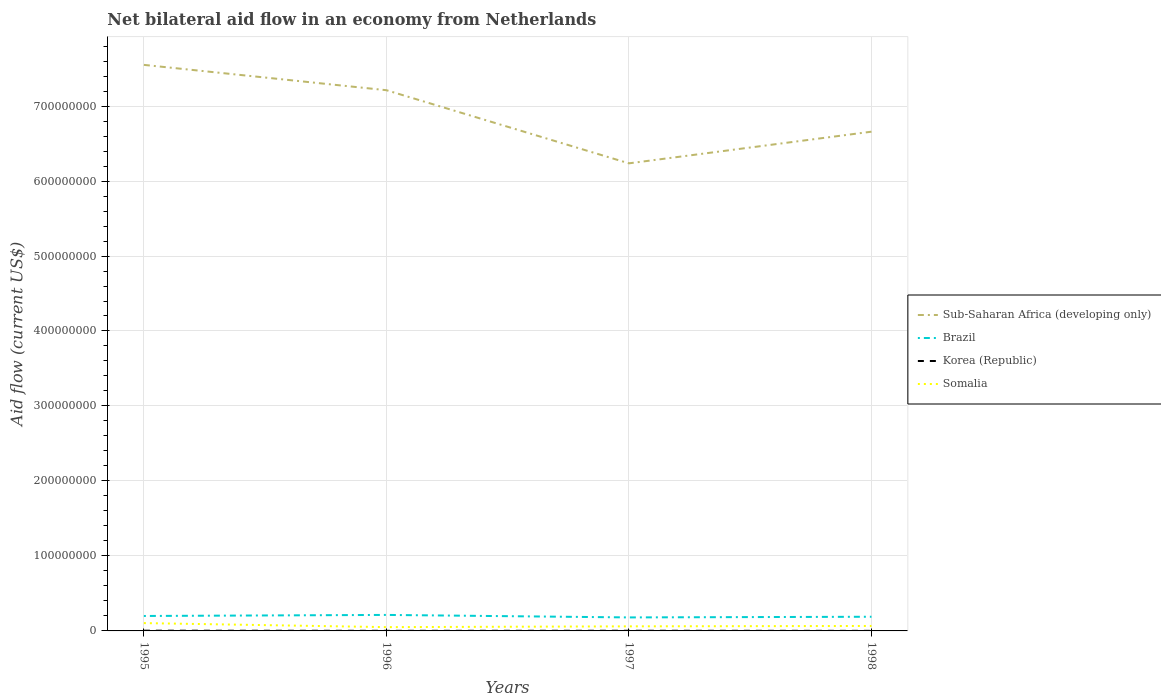Across all years, what is the maximum net bilateral aid flow in Sub-Saharan Africa (developing only)?
Make the answer very short. 6.24e+08. In which year was the net bilateral aid flow in Korea (Republic) maximum?
Offer a terse response. 1998. What is the total net bilateral aid flow in Brazil in the graph?
Keep it short and to the point. 2.44e+06. What is the difference between the highest and the second highest net bilateral aid flow in Brazil?
Ensure brevity in your answer.  3.34e+06. What is the difference between the highest and the lowest net bilateral aid flow in Brazil?
Make the answer very short. 2. How many years are there in the graph?
Keep it short and to the point. 4. What is the difference between two consecutive major ticks on the Y-axis?
Ensure brevity in your answer.  1.00e+08. Are the values on the major ticks of Y-axis written in scientific E-notation?
Keep it short and to the point. No. Does the graph contain any zero values?
Your answer should be compact. No. How many legend labels are there?
Make the answer very short. 4. How are the legend labels stacked?
Your answer should be very brief. Vertical. What is the title of the graph?
Your answer should be very brief. Net bilateral aid flow in an economy from Netherlands. Does "Malta" appear as one of the legend labels in the graph?
Provide a succinct answer. No. What is the label or title of the X-axis?
Offer a terse response. Years. What is the Aid flow (current US$) of Sub-Saharan Africa (developing only) in 1995?
Offer a very short reply. 7.55e+08. What is the Aid flow (current US$) in Brazil in 1995?
Offer a terse response. 1.99e+07. What is the Aid flow (current US$) in Korea (Republic) in 1995?
Provide a short and direct response. 3.20e+05. What is the Aid flow (current US$) of Somalia in 1995?
Give a very brief answer. 1.04e+07. What is the Aid flow (current US$) in Sub-Saharan Africa (developing only) in 1996?
Make the answer very short. 7.21e+08. What is the Aid flow (current US$) of Brazil in 1996?
Make the answer very short. 2.13e+07. What is the Aid flow (current US$) in Somalia in 1996?
Ensure brevity in your answer.  5.05e+06. What is the Aid flow (current US$) in Sub-Saharan Africa (developing only) in 1997?
Provide a short and direct response. 6.24e+08. What is the Aid flow (current US$) of Brazil in 1997?
Make the answer very short. 1.80e+07. What is the Aid flow (current US$) of Somalia in 1997?
Your answer should be very brief. 6.10e+06. What is the Aid flow (current US$) in Sub-Saharan Africa (developing only) in 1998?
Ensure brevity in your answer.  6.66e+08. What is the Aid flow (current US$) in Brazil in 1998?
Your answer should be compact. 1.89e+07. What is the Aid flow (current US$) in Somalia in 1998?
Your answer should be very brief. 6.62e+06. Across all years, what is the maximum Aid flow (current US$) of Sub-Saharan Africa (developing only)?
Provide a succinct answer. 7.55e+08. Across all years, what is the maximum Aid flow (current US$) in Brazil?
Offer a very short reply. 2.13e+07. Across all years, what is the maximum Aid flow (current US$) in Korea (Republic)?
Your response must be concise. 3.20e+05. Across all years, what is the maximum Aid flow (current US$) in Somalia?
Offer a very short reply. 1.04e+07. Across all years, what is the minimum Aid flow (current US$) in Sub-Saharan Africa (developing only)?
Ensure brevity in your answer.  6.24e+08. Across all years, what is the minimum Aid flow (current US$) of Brazil?
Provide a short and direct response. 1.80e+07. Across all years, what is the minimum Aid flow (current US$) of Somalia?
Keep it short and to the point. 5.05e+06. What is the total Aid flow (current US$) of Sub-Saharan Africa (developing only) in the graph?
Offer a very short reply. 2.77e+09. What is the total Aid flow (current US$) in Brazil in the graph?
Provide a short and direct response. 7.82e+07. What is the total Aid flow (current US$) of Korea (Republic) in the graph?
Ensure brevity in your answer.  7.90e+05. What is the total Aid flow (current US$) in Somalia in the graph?
Provide a succinct answer. 2.82e+07. What is the difference between the Aid flow (current US$) in Sub-Saharan Africa (developing only) in 1995 and that in 1996?
Ensure brevity in your answer.  3.38e+07. What is the difference between the Aid flow (current US$) of Brazil in 1995 and that in 1996?
Offer a very short reply. -1.41e+06. What is the difference between the Aid flow (current US$) of Somalia in 1995 and that in 1996?
Make the answer very short. 5.38e+06. What is the difference between the Aid flow (current US$) in Sub-Saharan Africa (developing only) in 1995 and that in 1997?
Keep it short and to the point. 1.31e+08. What is the difference between the Aid flow (current US$) of Brazil in 1995 and that in 1997?
Your response must be concise. 1.93e+06. What is the difference between the Aid flow (current US$) in Somalia in 1995 and that in 1997?
Offer a very short reply. 4.33e+06. What is the difference between the Aid flow (current US$) of Sub-Saharan Africa (developing only) in 1995 and that in 1998?
Keep it short and to the point. 8.91e+07. What is the difference between the Aid flow (current US$) of Brazil in 1995 and that in 1998?
Offer a terse response. 1.03e+06. What is the difference between the Aid flow (current US$) in Somalia in 1995 and that in 1998?
Make the answer very short. 3.81e+06. What is the difference between the Aid flow (current US$) in Sub-Saharan Africa (developing only) in 1996 and that in 1997?
Provide a succinct answer. 9.75e+07. What is the difference between the Aid flow (current US$) of Brazil in 1996 and that in 1997?
Make the answer very short. 3.34e+06. What is the difference between the Aid flow (current US$) of Korea (Republic) in 1996 and that in 1997?
Ensure brevity in your answer.  -8.00e+04. What is the difference between the Aid flow (current US$) in Somalia in 1996 and that in 1997?
Ensure brevity in your answer.  -1.05e+06. What is the difference between the Aid flow (current US$) in Sub-Saharan Africa (developing only) in 1996 and that in 1998?
Your answer should be very brief. 5.53e+07. What is the difference between the Aid flow (current US$) in Brazil in 1996 and that in 1998?
Offer a terse response. 2.44e+06. What is the difference between the Aid flow (current US$) in Korea (Republic) in 1996 and that in 1998?
Make the answer very short. 6.00e+04. What is the difference between the Aid flow (current US$) in Somalia in 1996 and that in 1998?
Your answer should be compact. -1.57e+06. What is the difference between the Aid flow (current US$) in Sub-Saharan Africa (developing only) in 1997 and that in 1998?
Offer a very short reply. -4.22e+07. What is the difference between the Aid flow (current US$) of Brazil in 1997 and that in 1998?
Keep it short and to the point. -9.00e+05. What is the difference between the Aid flow (current US$) of Somalia in 1997 and that in 1998?
Offer a very short reply. -5.20e+05. What is the difference between the Aid flow (current US$) of Sub-Saharan Africa (developing only) in 1995 and the Aid flow (current US$) of Brazil in 1996?
Your response must be concise. 7.34e+08. What is the difference between the Aid flow (current US$) in Sub-Saharan Africa (developing only) in 1995 and the Aid flow (current US$) in Korea (Republic) in 1996?
Offer a terse response. 7.55e+08. What is the difference between the Aid flow (current US$) in Sub-Saharan Africa (developing only) in 1995 and the Aid flow (current US$) in Somalia in 1996?
Your answer should be compact. 7.50e+08. What is the difference between the Aid flow (current US$) of Brazil in 1995 and the Aid flow (current US$) of Korea (Republic) in 1996?
Ensure brevity in your answer.  1.98e+07. What is the difference between the Aid flow (current US$) in Brazil in 1995 and the Aid flow (current US$) in Somalia in 1996?
Provide a succinct answer. 1.49e+07. What is the difference between the Aid flow (current US$) in Korea (Republic) in 1995 and the Aid flow (current US$) in Somalia in 1996?
Keep it short and to the point. -4.73e+06. What is the difference between the Aid flow (current US$) of Sub-Saharan Africa (developing only) in 1995 and the Aid flow (current US$) of Brazil in 1997?
Make the answer very short. 7.37e+08. What is the difference between the Aid flow (current US$) of Sub-Saharan Africa (developing only) in 1995 and the Aid flow (current US$) of Korea (Republic) in 1997?
Your answer should be very brief. 7.55e+08. What is the difference between the Aid flow (current US$) of Sub-Saharan Africa (developing only) in 1995 and the Aid flow (current US$) of Somalia in 1997?
Make the answer very short. 7.49e+08. What is the difference between the Aid flow (current US$) of Brazil in 1995 and the Aid flow (current US$) of Korea (Republic) in 1997?
Give a very brief answer. 1.97e+07. What is the difference between the Aid flow (current US$) of Brazil in 1995 and the Aid flow (current US$) of Somalia in 1997?
Keep it short and to the point. 1.38e+07. What is the difference between the Aid flow (current US$) of Korea (Republic) in 1995 and the Aid flow (current US$) of Somalia in 1997?
Offer a terse response. -5.78e+06. What is the difference between the Aid flow (current US$) of Sub-Saharan Africa (developing only) in 1995 and the Aid flow (current US$) of Brazil in 1998?
Provide a succinct answer. 7.36e+08. What is the difference between the Aid flow (current US$) in Sub-Saharan Africa (developing only) in 1995 and the Aid flow (current US$) in Korea (Republic) in 1998?
Your answer should be compact. 7.55e+08. What is the difference between the Aid flow (current US$) of Sub-Saharan Africa (developing only) in 1995 and the Aid flow (current US$) of Somalia in 1998?
Offer a very short reply. 7.48e+08. What is the difference between the Aid flow (current US$) in Brazil in 1995 and the Aid flow (current US$) in Korea (Republic) in 1998?
Make the answer very short. 1.98e+07. What is the difference between the Aid flow (current US$) in Brazil in 1995 and the Aid flow (current US$) in Somalia in 1998?
Ensure brevity in your answer.  1.33e+07. What is the difference between the Aid flow (current US$) of Korea (Republic) in 1995 and the Aid flow (current US$) of Somalia in 1998?
Offer a terse response. -6.30e+06. What is the difference between the Aid flow (current US$) in Sub-Saharan Africa (developing only) in 1996 and the Aid flow (current US$) in Brazil in 1997?
Your answer should be compact. 7.03e+08. What is the difference between the Aid flow (current US$) of Sub-Saharan Africa (developing only) in 1996 and the Aid flow (current US$) of Korea (Republic) in 1997?
Give a very brief answer. 7.21e+08. What is the difference between the Aid flow (current US$) of Sub-Saharan Africa (developing only) in 1996 and the Aid flow (current US$) of Somalia in 1997?
Make the answer very short. 7.15e+08. What is the difference between the Aid flow (current US$) in Brazil in 1996 and the Aid flow (current US$) in Korea (Republic) in 1997?
Give a very brief answer. 2.11e+07. What is the difference between the Aid flow (current US$) in Brazil in 1996 and the Aid flow (current US$) in Somalia in 1997?
Give a very brief answer. 1.52e+07. What is the difference between the Aid flow (current US$) of Korea (Republic) in 1996 and the Aid flow (current US$) of Somalia in 1997?
Make the answer very short. -5.95e+06. What is the difference between the Aid flow (current US$) in Sub-Saharan Africa (developing only) in 1996 and the Aid flow (current US$) in Brazil in 1998?
Ensure brevity in your answer.  7.02e+08. What is the difference between the Aid flow (current US$) of Sub-Saharan Africa (developing only) in 1996 and the Aid flow (current US$) of Korea (Republic) in 1998?
Your response must be concise. 7.21e+08. What is the difference between the Aid flow (current US$) of Sub-Saharan Africa (developing only) in 1996 and the Aid flow (current US$) of Somalia in 1998?
Provide a short and direct response. 7.15e+08. What is the difference between the Aid flow (current US$) of Brazil in 1996 and the Aid flow (current US$) of Korea (Republic) in 1998?
Your answer should be very brief. 2.12e+07. What is the difference between the Aid flow (current US$) of Brazil in 1996 and the Aid flow (current US$) of Somalia in 1998?
Give a very brief answer. 1.47e+07. What is the difference between the Aid flow (current US$) of Korea (Republic) in 1996 and the Aid flow (current US$) of Somalia in 1998?
Make the answer very short. -6.47e+06. What is the difference between the Aid flow (current US$) of Sub-Saharan Africa (developing only) in 1997 and the Aid flow (current US$) of Brazil in 1998?
Ensure brevity in your answer.  6.05e+08. What is the difference between the Aid flow (current US$) in Sub-Saharan Africa (developing only) in 1997 and the Aid flow (current US$) in Korea (Republic) in 1998?
Offer a very short reply. 6.24e+08. What is the difference between the Aid flow (current US$) of Sub-Saharan Africa (developing only) in 1997 and the Aid flow (current US$) of Somalia in 1998?
Make the answer very short. 6.17e+08. What is the difference between the Aid flow (current US$) of Brazil in 1997 and the Aid flow (current US$) of Korea (Republic) in 1998?
Your response must be concise. 1.79e+07. What is the difference between the Aid flow (current US$) in Brazil in 1997 and the Aid flow (current US$) in Somalia in 1998?
Your answer should be very brief. 1.14e+07. What is the difference between the Aid flow (current US$) in Korea (Republic) in 1997 and the Aid flow (current US$) in Somalia in 1998?
Provide a succinct answer. -6.39e+06. What is the average Aid flow (current US$) of Sub-Saharan Africa (developing only) per year?
Provide a short and direct response. 6.91e+08. What is the average Aid flow (current US$) of Brazil per year?
Your answer should be compact. 1.95e+07. What is the average Aid flow (current US$) of Korea (Republic) per year?
Ensure brevity in your answer.  1.98e+05. What is the average Aid flow (current US$) in Somalia per year?
Offer a very short reply. 7.05e+06. In the year 1995, what is the difference between the Aid flow (current US$) in Sub-Saharan Africa (developing only) and Aid flow (current US$) in Brazil?
Your response must be concise. 7.35e+08. In the year 1995, what is the difference between the Aid flow (current US$) in Sub-Saharan Africa (developing only) and Aid flow (current US$) in Korea (Republic)?
Give a very brief answer. 7.55e+08. In the year 1995, what is the difference between the Aid flow (current US$) in Sub-Saharan Africa (developing only) and Aid flow (current US$) in Somalia?
Offer a terse response. 7.44e+08. In the year 1995, what is the difference between the Aid flow (current US$) of Brazil and Aid flow (current US$) of Korea (Republic)?
Your answer should be compact. 1.96e+07. In the year 1995, what is the difference between the Aid flow (current US$) in Brazil and Aid flow (current US$) in Somalia?
Give a very brief answer. 9.50e+06. In the year 1995, what is the difference between the Aid flow (current US$) of Korea (Republic) and Aid flow (current US$) of Somalia?
Provide a short and direct response. -1.01e+07. In the year 1996, what is the difference between the Aid flow (current US$) in Sub-Saharan Africa (developing only) and Aid flow (current US$) in Brazil?
Your answer should be very brief. 7.00e+08. In the year 1996, what is the difference between the Aid flow (current US$) in Sub-Saharan Africa (developing only) and Aid flow (current US$) in Korea (Republic)?
Your response must be concise. 7.21e+08. In the year 1996, what is the difference between the Aid flow (current US$) in Sub-Saharan Africa (developing only) and Aid flow (current US$) in Somalia?
Provide a succinct answer. 7.16e+08. In the year 1996, what is the difference between the Aid flow (current US$) in Brazil and Aid flow (current US$) in Korea (Republic)?
Offer a very short reply. 2.12e+07. In the year 1996, what is the difference between the Aid flow (current US$) of Brazil and Aid flow (current US$) of Somalia?
Your answer should be very brief. 1.63e+07. In the year 1996, what is the difference between the Aid flow (current US$) in Korea (Republic) and Aid flow (current US$) in Somalia?
Provide a short and direct response. -4.90e+06. In the year 1997, what is the difference between the Aid flow (current US$) of Sub-Saharan Africa (developing only) and Aid flow (current US$) of Brazil?
Your answer should be very brief. 6.06e+08. In the year 1997, what is the difference between the Aid flow (current US$) in Sub-Saharan Africa (developing only) and Aid flow (current US$) in Korea (Republic)?
Ensure brevity in your answer.  6.23e+08. In the year 1997, what is the difference between the Aid flow (current US$) in Sub-Saharan Africa (developing only) and Aid flow (current US$) in Somalia?
Provide a succinct answer. 6.17e+08. In the year 1997, what is the difference between the Aid flow (current US$) of Brazil and Aid flow (current US$) of Korea (Republic)?
Provide a short and direct response. 1.78e+07. In the year 1997, what is the difference between the Aid flow (current US$) in Brazil and Aid flow (current US$) in Somalia?
Provide a succinct answer. 1.19e+07. In the year 1997, what is the difference between the Aid flow (current US$) in Korea (Republic) and Aid flow (current US$) in Somalia?
Your response must be concise. -5.87e+06. In the year 1998, what is the difference between the Aid flow (current US$) in Sub-Saharan Africa (developing only) and Aid flow (current US$) in Brazil?
Your response must be concise. 6.47e+08. In the year 1998, what is the difference between the Aid flow (current US$) in Sub-Saharan Africa (developing only) and Aid flow (current US$) in Korea (Republic)?
Your answer should be compact. 6.66e+08. In the year 1998, what is the difference between the Aid flow (current US$) of Sub-Saharan Africa (developing only) and Aid flow (current US$) of Somalia?
Provide a succinct answer. 6.59e+08. In the year 1998, what is the difference between the Aid flow (current US$) in Brazil and Aid flow (current US$) in Korea (Republic)?
Your answer should be very brief. 1.88e+07. In the year 1998, what is the difference between the Aid flow (current US$) of Brazil and Aid flow (current US$) of Somalia?
Give a very brief answer. 1.23e+07. In the year 1998, what is the difference between the Aid flow (current US$) in Korea (Republic) and Aid flow (current US$) in Somalia?
Give a very brief answer. -6.53e+06. What is the ratio of the Aid flow (current US$) of Sub-Saharan Africa (developing only) in 1995 to that in 1996?
Your response must be concise. 1.05. What is the ratio of the Aid flow (current US$) in Brazil in 1995 to that in 1996?
Make the answer very short. 0.93. What is the ratio of the Aid flow (current US$) in Korea (Republic) in 1995 to that in 1996?
Provide a short and direct response. 2.13. What is the ratio of the Aid flow (current US$) of Somalia in 1995 to that in 1996?
Give a very brief answer. 2.07. What is the ratio of the Aid flow (current US$) in Sub-Saharan Africa (developing only) in 1995 to that in 1997?
Give a very brief answer. 1.21. What is the ratio of the Aid flow (current US$) of Brazil in 1995 to that in 1997?
Provide a short and direct response. 1.11. What is the ratio of the Aid flow (current US$) in Korea (Republic) in 1995 to that in 1997?
Make the answer very short. 1.39. What is the ratio of the Aid flow (current US$) in Somalia in 1995 to that in 1997?
Give a very brief answer. 1.71. What is the ratio of the Aid flow (current US$) in Sub-Saharan Africa (developing only) in 1995 to that in 1998?
Offer a terse response. 1.13. What is the ratio of the Aid flow (current US$) of Brazil in 1995 to that in 1998?
Ensure brevity in your answer.  1.05. What is the ratio of the Aid flow (current US$) in Korea (Republic) in 1995 to that in 1998?
Your answer should be compact. 3.56. What is the ratio of the Aid flow (current US$) in Somalia in 1995 to that in 1998?
Provide a short and direct response. 1.58. What is the ratio of the Aid flow (current US$) of Sub-Saharan Africa (developing only) in 1996 to that in 1997?
Offer a very short reply. 1.16. What is the ratio of the Aid flow (current US$) in Brazil in 1996 to that in 1997?
Offer a terse response. 1.19. What is the ratio of the Aid flow (current US$) of Korea (Republic) in 1996 to that in 1997?
Keep it short and to the point. 0.65. What is the ratio of the Aid flow (current US$) in Somalia in 1996 to that in 1997?
Provide a succinct answer. 0.83. What is the ratio of the Aid flow (current US$) in Sub-Saharan Africa (developing only) in 1996 to that in 1998?
Give a very brief answer. 1.08. What is the ratio of the Aid flow (current US$) of Brazil in 1996 to that in 1998?
Provide a short and direct response. 1.13. What is the ratio of the Aid flow (current US$) in Korea (Republic) in 1996 to that in 1998?
Make the answer very short. 1.67. What is the ratio of the Aid flow (current US$) of Somalia in 1996 to that in 1998?
Keep it short and to the point. 0.76. What is the ratio of the Aid flow (current US$) in Sub-Saharan Africa (developing only) in 1997 to that in 1998?
Provide a short and direct response. 0.94. What is the ratio of the Aid flow (current US$) in Korea (Republic) in 1997 to that in 1998?
Make the answer very short. 2.56. What is the ratio of the Aid flow (current US$) of Somalia in 1997 to that in 1998?
Keep it short and to the point. 0.92. What is the difference between the highest and the second highest Aid flow (current US$) of Sub-Saharan Africa (developing only)?
Make the answer very short. 3.38e+07. What is the difference between the highest and the second highest Aid flow (current US$) of Brazil?
Your response must be concise. 1.41e+06. What is the difference between the highest and the second highest Aid flow (current US$) in Korea (Republic)?
Give a very brief answer. 9.00e+04. What is the difference between the highest and the second highest Aid flow (current US$) of Somalia?
Your response must be concise. 3.81e+06. What is the difference between the highest and the lowest Aid flow (current US$) of Sub-Saharan Africa (developing only)?
Make the answer very short. 1.31e+08. What is the difference between the highest and the lowest Aid flow (current US$) in Brazil?
Make the answer very short. 3.34e+06. What is the difference between the highest and the lowest Aid flow (current US$) of Somalia?
Ensure brevity in your answer.  5.38e+06. 